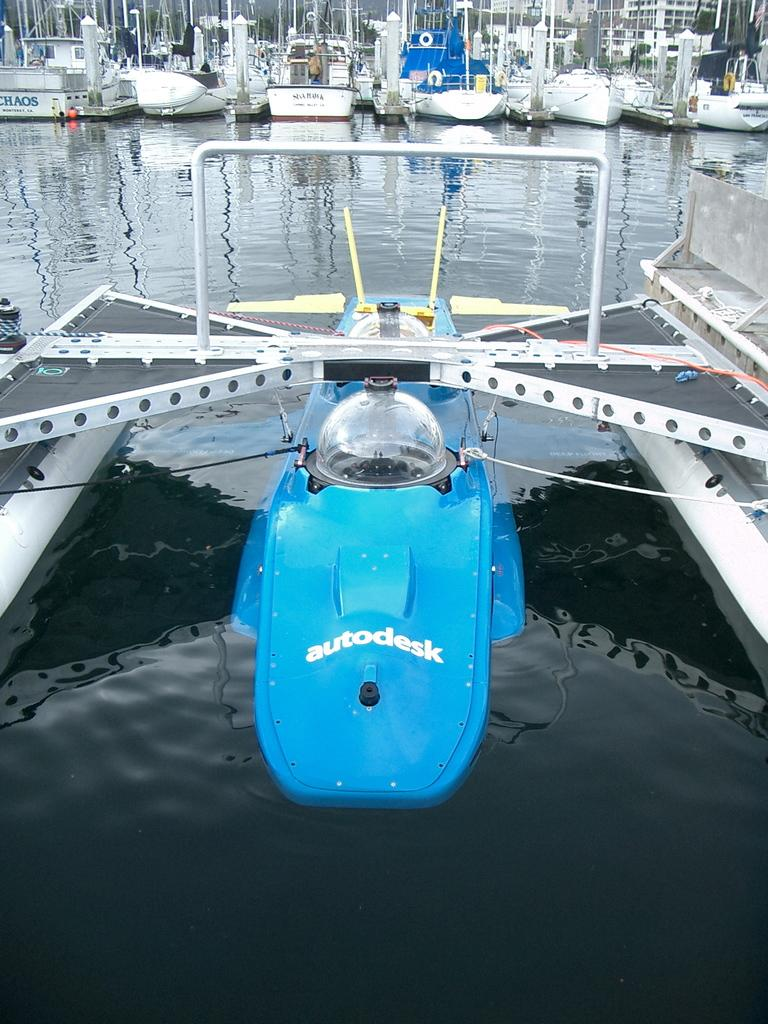<image>
Offer a succinct explanation of the picture presented. a strange looking boat thing with the word autodeck is on the water 